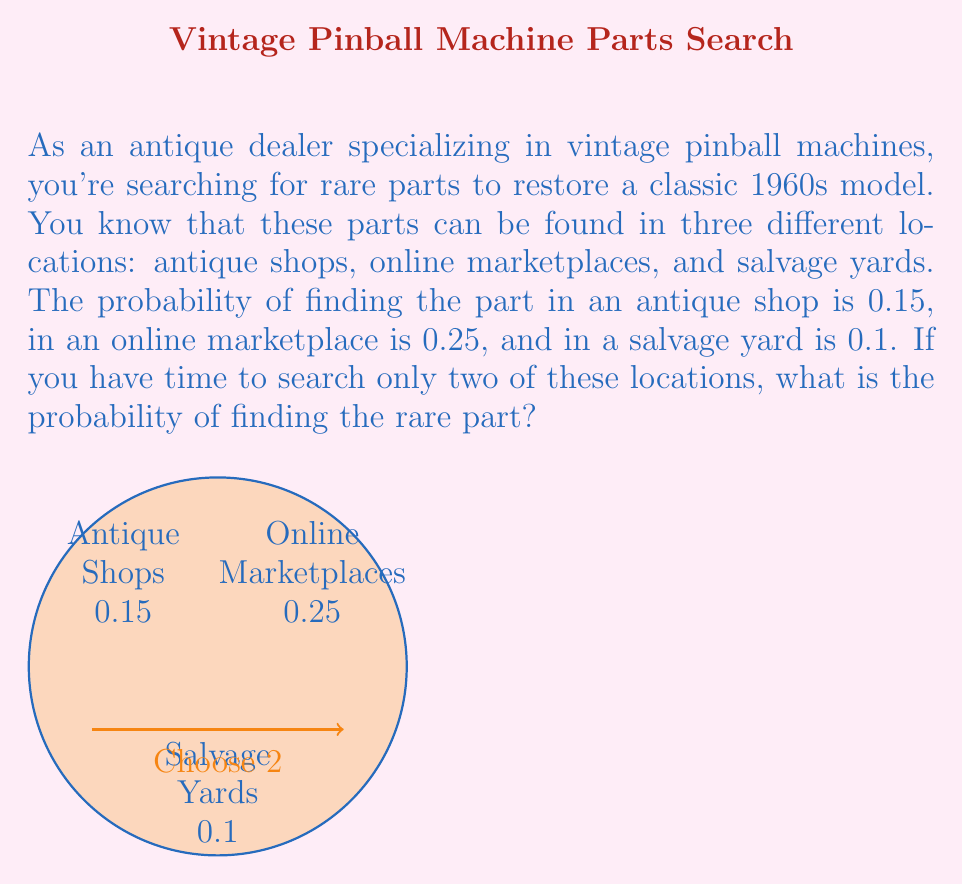What is the answer to this math problem? Let's approach this step-by-step using probability theory:

1) First, we need to calculate the probability of not finding the part in each location:
   - Antique shops: $P(\text{not found}) = 1 - 0.15 = 0.85$
   - Online marketplaces: $P(\text{not found}) = 1 - 0.25 = 0.75$
   - Salvage yards: $P(\text{not found}) = 1 - 0.1 = 0.9$

2) Now, we need to consider the probability of not finding the part in any two of these locations. There are three possible combinations:
   a) Antique shops and online marketplaces
   b) Antique shops and salvage yards
   c) Online marketplaces and salvage yards

3) Let's calculate the probability of not finding the part for each combination:
   a) $P(\text{not found in shops and online}) = 0.85 \times 0.75 = 0.6375$
   b) $P(\text{not found in shops and yards}) = 0.85 \times 0.9 = 0.765$
   c) $P(\text{not found online and yards}) = 0.75 \times 0.9 = 0.675$

4) The probability of finding the part is the opposite of not finding it. So for each combination:
   a) $P(\text{found in shops or online}) = 1 - 0.6375 = 0.3625$
   b) $P(\text{found in shops or yards}) = 1 - 0.765 = 0.235$
   c) $P(\text{found online or yards}) = 1 - 0.675 = 0.325$

5) The question asks for the probability of finding the part if we search two locations. This is equivalent to asking for the highest probability among these three combinations.

6) The highest probability is 0.3625, which corresponds to searching antique shops and online marketplaces.

Therefore, the probability of finding the rare part when searching two locations is 0.3625 or 36.25%.
Answer: 0.3625 